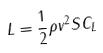<formula> <loc_0><loc_0><loc_500><loc_500>L = \frac { 1 } { 2 } \rho v ^ { 2 } S C _ { L }</formula> 